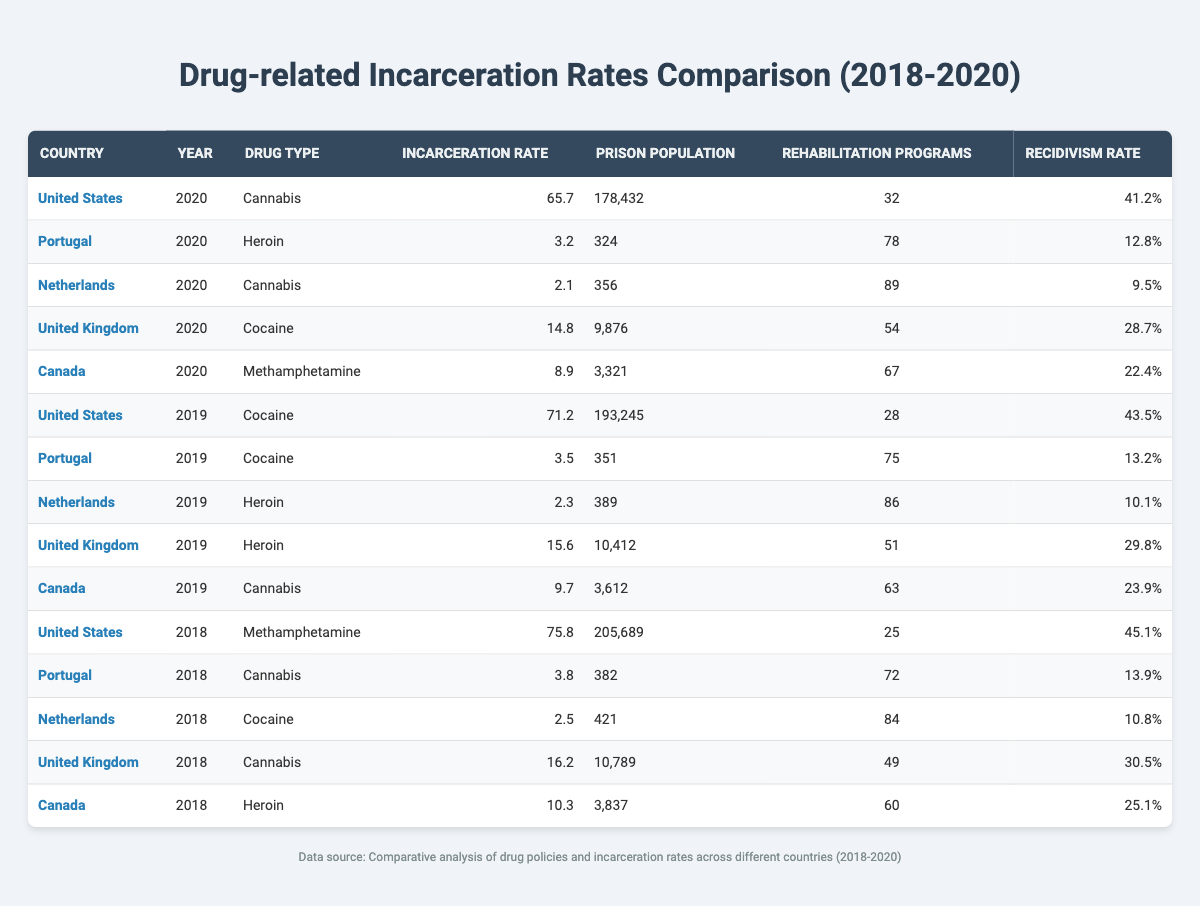What is the incarceration rate for Cannabis in the United States in 2020? According to the table, the incarceration rate for Cannabis in the United States in 2020 is listed under the relevant row. The value is 65.7.
Answer: 65.7 Which country had the highest incarceration rate for cocaine in 2019? Analyzing the table for the year 2019 and filtering for cocaine reveals two entries: the United States with a rate of 71.2 and Portugal with a rate of 3.5. The United States has the highest of these two rates.
Answer: United States How many rehabilitation programs does the Netherlands have for cannabis in 2020? Referring to the row for the Netherlands in the year 2020 under cannabis, there are 89 rehabilitation programs indicated.
Answer: 89 What is the total prison population in the United States across all years provided in the table? By summing the prison populations of the United States for 2018, 2019, and 2020, we calculate: 205,689 (2018) + 193,245 (2019) + 178,432 (2020) = 577,366.
Answer: 577,366 Is the recidivism rate for the United Kingdom's cocaine-related incarceration higher than that for the heroin-related incarceration in 2019? The recidivism rate for cocaine in the United Kingdom in 2020 is 28.7%, while for heroin in 2019, it is 29.8%. Comparing these two shows that the rate for heroin (29.8%) is indeed higher than for cocaine (28.7%).
Answer: Yes What was the average incarceration rate for Portugal for the years provided in the table? We find Portugal's incarceration rates: 3.2 (2020), 3.5 (2019), and 3.8 (2018). The average is calculated by summing these: 3.2 + 3.5 + 3.8 = 10.5, then dividing by 3 gives 10.5/3 = 3.5.
Answer: 3.5 Did Canada have a lower incarceration rate for methamphetamine than the United States in 2020? The incarceration rate for Canada in 2020 is listed as 8.9 for methamphetamine, while the United States' incarceration rate for that year is 65.7. Comparing these, Canada’s rate (8.9) is indeed lower than the US rate (65.7).
Answer: Yes Which country experienced an increase in incarceration rates from 2018 to 2019? Reviewing the table, we see that the United States' incarceration rate for methamphetamine increased from 75.8 (2018) to 71.2 (2019) which is a decrease, while there is no other country with an increase in rates from 2018 to 2019. Hence, the United States is the only analysis needed here with a slight decrease as per values.
Answer: No 